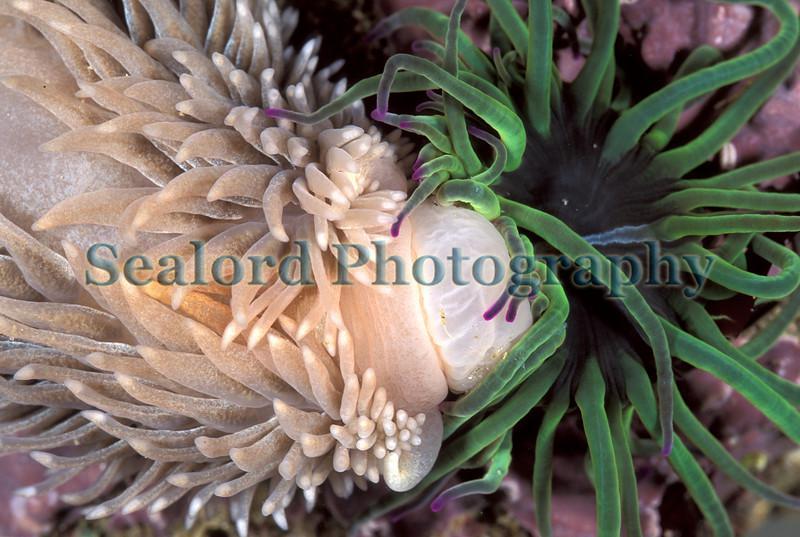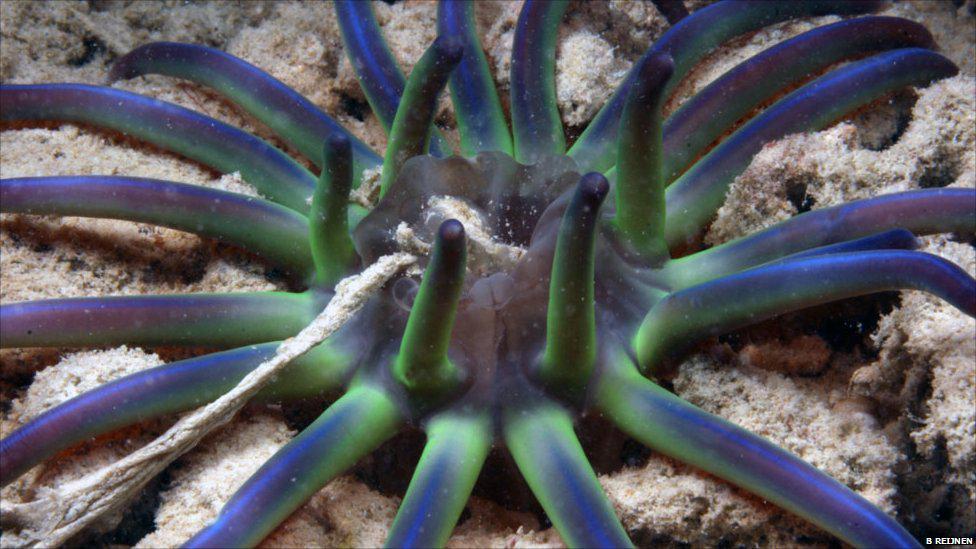The first image is the image on the left, the second image is the image on the right. Assess this claim about the two images: "In the right image, the sea slug has blue-ish arms/tentacles.". Correct or not? Answer yes or no. Yes. The first image is the image on the left, the second image is the image on the right. Given the left and right images, does the statement "An anemone of green, blue, and purple sits on the sandy floor, eating." hold true? Answer yes or no. Yes. 